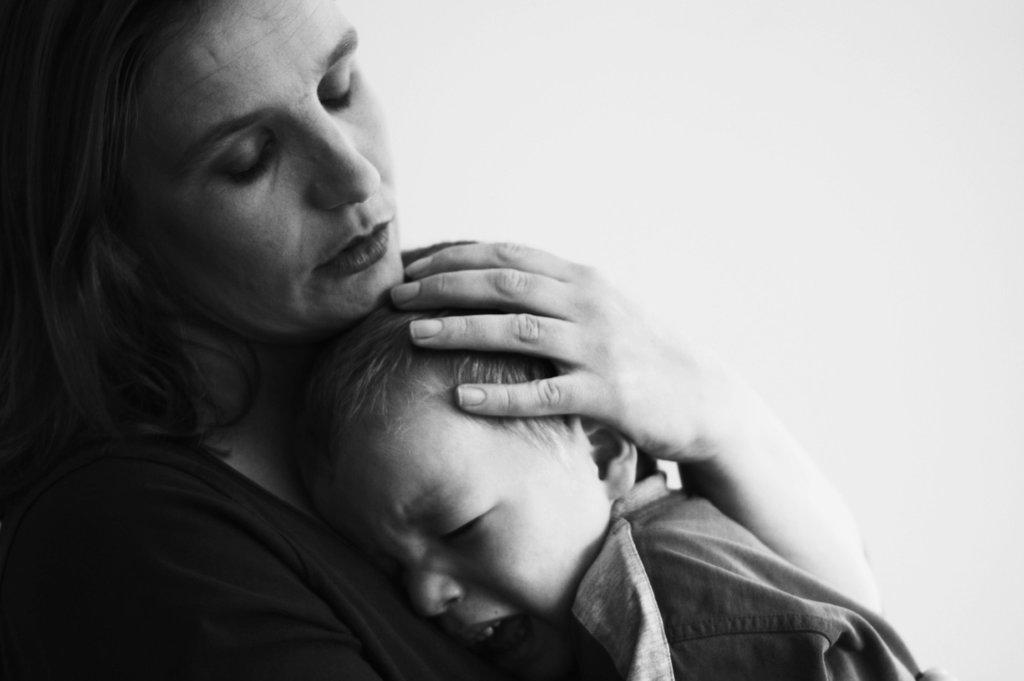Who is present in the image? There is a woman and a kid in the image. What is the woman doing with the kid? The woman is holding the kid. What is the color scheme of the image? The image is black and white. What type of crow is sitting on the woman's finger in the image? There is no crow present in the image; it only features a woman and a kid. 